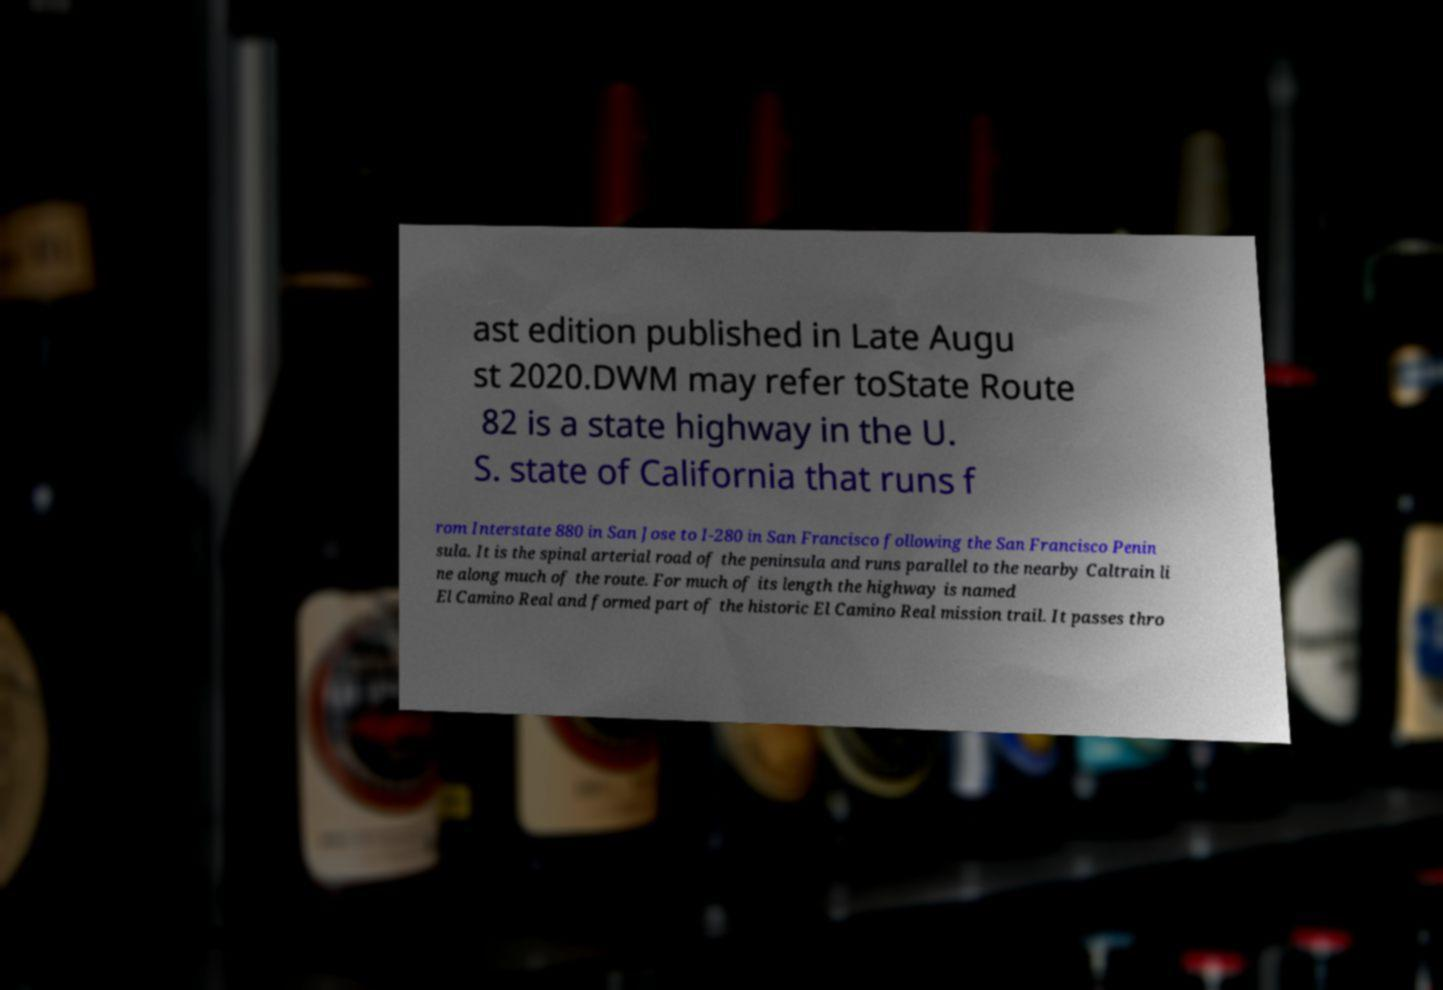What messages or text are displayed in this image? I need them in a readable, typed format. ast edition published in Late Augu st 2020.DWM may refer toState Route 82 is a state highway in the U. S. state of California that runs f rom Interstate 880 in San Jose to I-280 in San Francisco following the San Francisco Penin sula. It is the spinal arterial road of the peninsula and runs parallel to the nearby Caltrain li ne along much of the route. For much of its length the highway is named El Camino Real and formed part of the historic El Camino Real mission trail. It passes thro 